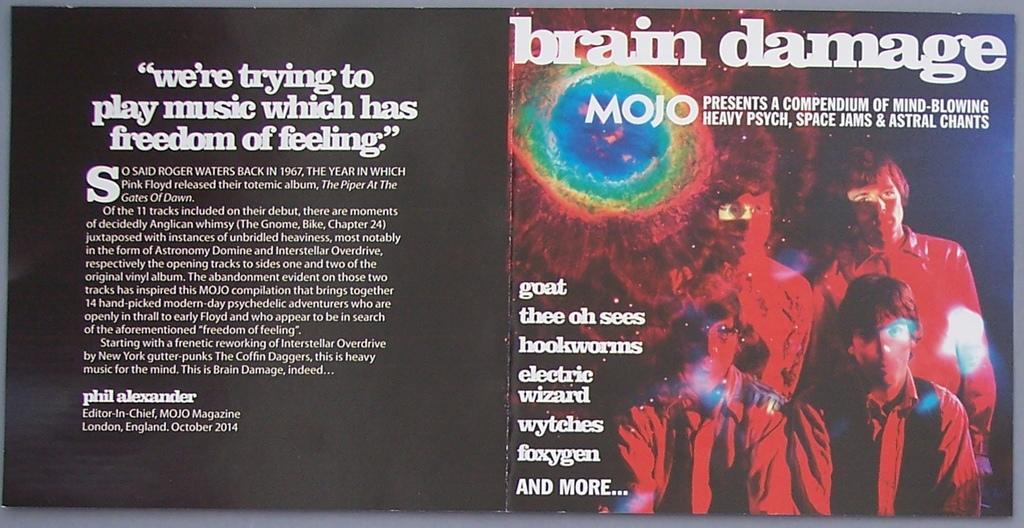In one or two sentences, can you explain what this image depicts? In this image there is like a board, in which there are some text and images of a few people. 